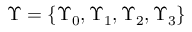Convert formula to latex. <formula><loc_0><loc_0><loc_500><loc_500>\Upsilon = \left \{ \Upsilon _ { 0 } , \Upsilon _ { 1 } , \Upsilon _ { 2 } , \Upsilon _ { 3 } \right \}</formula> 